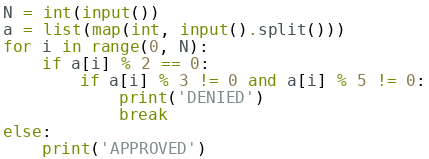Convert code to text. <code><loc_0><loc_0><loc_500><loc_500><_Python_>N = int(input())
a = list(map(int, input().split()))
for i in range(0, N):
    if a[i] % 2 == 0:
        if a[i] % 3 != 0 and a[i] % 5 != 0:
            print('DENIED')
            break
else:
    print('APPROVED')</code> 